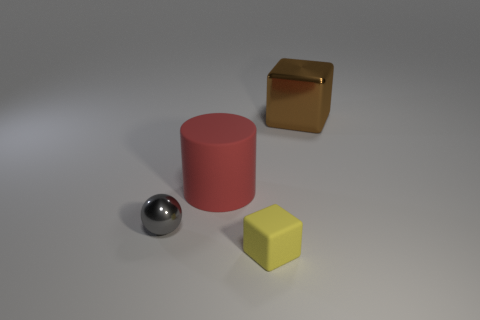How many spheres are red things or metal things?
Provide a short and direct response. 1. There is a matte thing behind the tiny gray shiny thing that is in front of the red object; what is its color?
Keep it short and to the point. Red. Is the number of large cylinders on the right side of the big brown metallic object less than the number of big rubber things that are in front of the small gray ball?
Provide a succinct answer. No. There is a yellow rubber thing; is its size the same as the gray metallic thing that is in front of the brown metal cube?
Offer a terse response. Yes. There is a object that is both on the left side of the tiny yellow rubber object and behind the gray thing; what is its shape?
Make the answer very short. Cylinder. The brown thing that is made of the same material as the gray thing is what size?
Keep it short and to the point. Large. What number of brown metallic cubes are left of the tiny object that is left of the matte cube?
Give a very brief answer. 0. Do the thing that is in front of the metal ball and the big brown object have the same material?
Your response must be concise. No. Is there anything else that has the same material as the brown thing?
Make the answer very short. Yes. How big is the cube that is right of the tiny object that is on the right side of the gray metallic object?
Ensure brevity in your answer.  Large. 